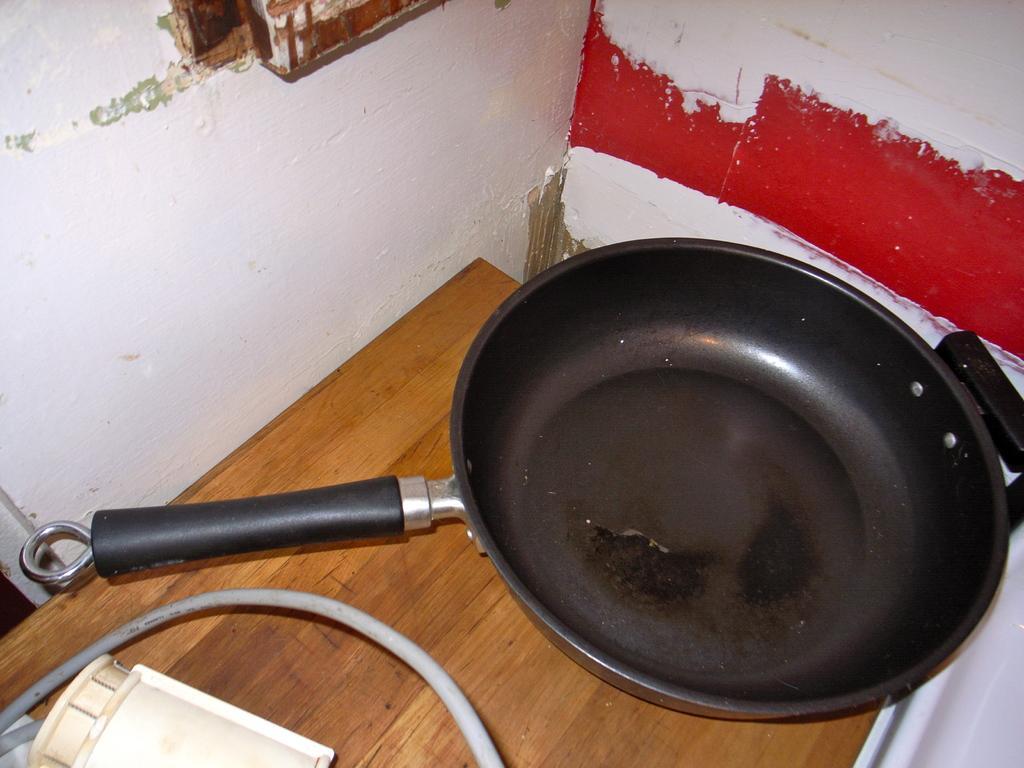In one or two sentences, can you explain what this image depicts? In this image I can see a pan and the wire on the table. 